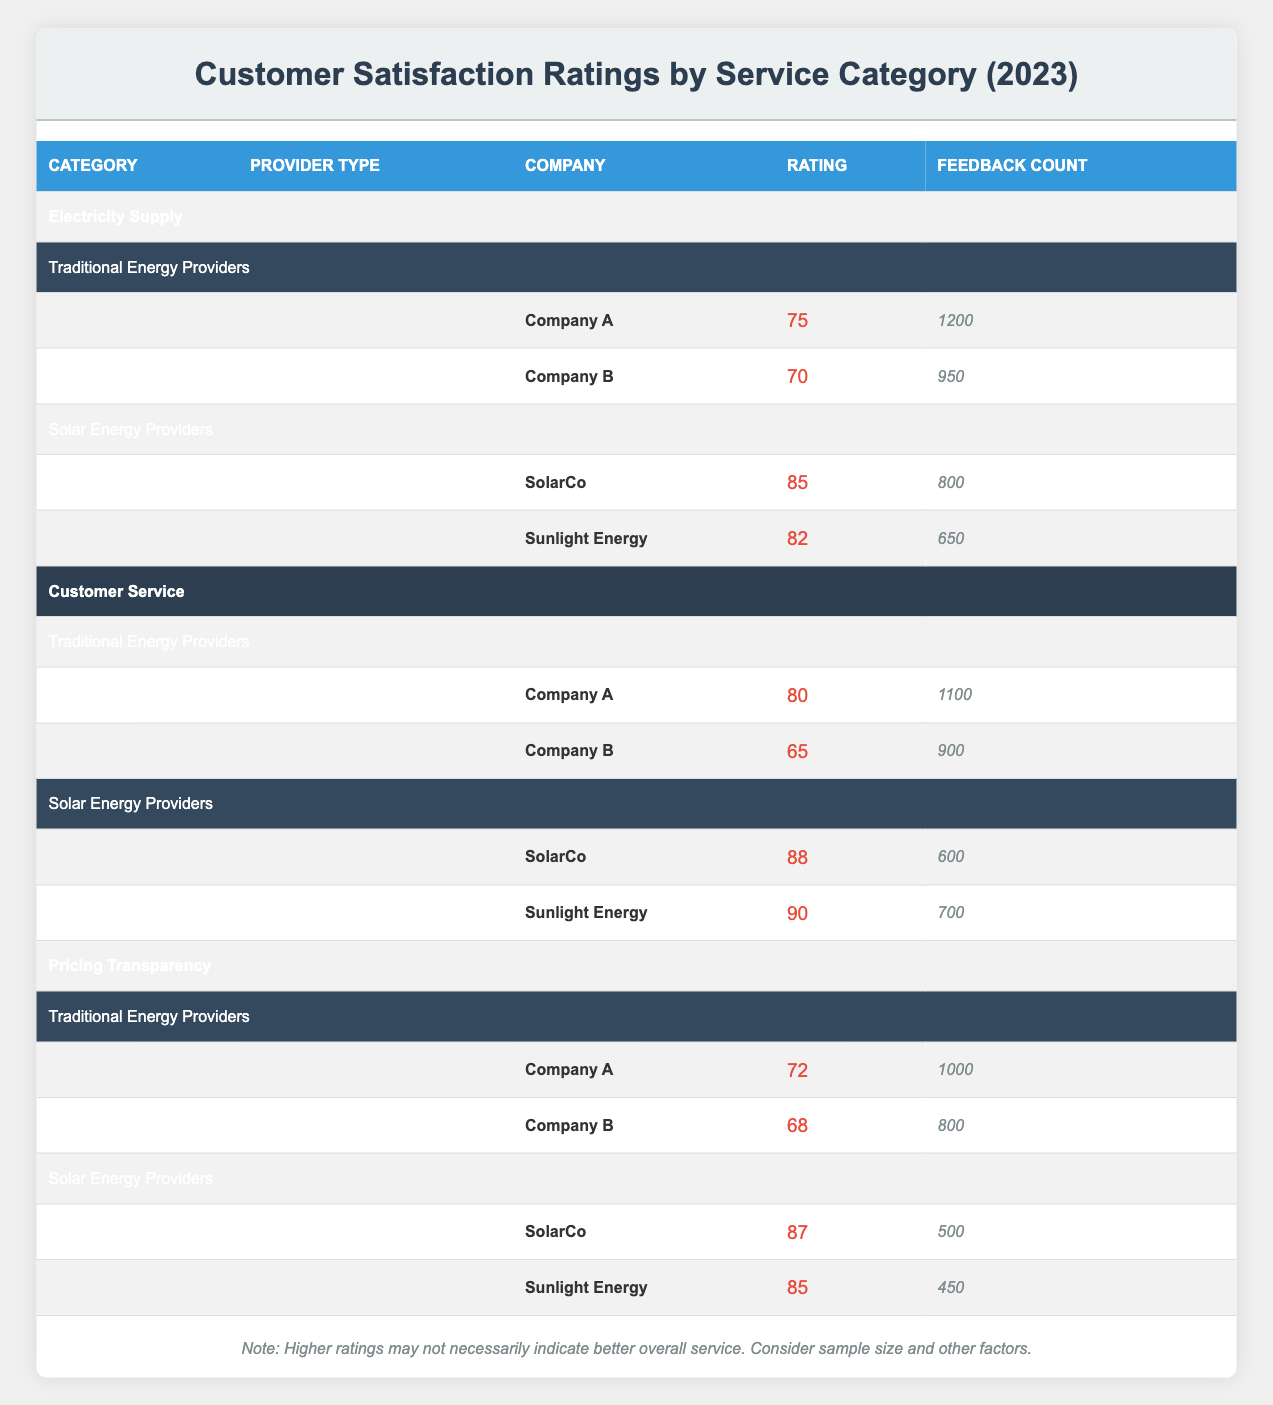What is the highest customer satisfaction rating among traditional energy providers in the Electricity Supply category? The table lists the ratings for traditional energy providers under the Electricity Supply category. Company A has a rating of 75, and Company B has a rating of 70. The highest rating among them is 75 from Company A.
Answer: 75 Which solar energy provider received the most feedback in customer service? Looking at the Customer Service category for solar energy providers, SolarCo received 600 feedbacks, while Sunlight Energy received 700. Therefore, Sunlight Energy received the most feedback in this category.
Answer: Sunlight Energy What is the average rating for solar energy providers across all categories? The ratings for solar energy providers are as follows: Electricity Supply (85 for SolarCo and 82 for Sunlight Energy), Customer Service (88 for SolarCo and 90 for Sunlight Energy), and Pricing Transparency (87 for SolarCo and 85 for Sunlight Energy). First, sum the ratings: 85 + 82 + 88 + 90 + 87 + 85 = 517. There are 6 ratings, so the average rating is 517 / 6 = 86.17.
Answer: 86.17 Did Company B score higher than any solar energy provider in customer service? Company B has a customer service rating of 65. SolarCo scored 88 and Sunlight Energy scored 90 in the same category, both of which are higher than Company B's rating. Therefore, the answer is no, Company B did not score higher than any solar energy providers.
Answer: No Which traditional energy provider has the lowest rating for Pricing Transparency, and what is that rating? The table lists the ratings for traditional energy providers in the Pricing Transparency category. Company A has a rating of 72, and Company B has a rating of 68. Company B has the lowest rating at 68.
Answer: Company B; 68 What is the difference in feedback counts between the highest-rated solar energy provider in Electricity Supply and the lowest-rated traditional energy provider in Customer Service? In Electricity Supply, the highest-rated solar energy provider is SolarCo with a rating of 85 and receives 800 feedbacks. The lowest-rated traditional energy provider in Customer Service is Company B with 900 feedbacks. The difference in feedback is 900 - 800 = 100.
Answer: 100 Which service category had the highest rated solar energy provider? Analyzing the table, SolarCo scored the highest rating of 88 in Customer Service, and other ratings are: 85 in Electricity Supply and 87 in Pricing Transparency. Thus, Customer Service has the highest-rated solar energy provider.
Answer: Customer Service Is the average rating for traditional energy providers lower than the average rating for solar energy providers in Pricing Transparency? The average rating for traditional energy providers in Pricing Transparency is (72 + 68) / 2 = 70. On the solar energy side, the two ratings are (87 + 85) / 2 = 86. Since 70 is lower than 86, the answer is yes, traditional energy providers have a lower average rating.
Answer: Yes 